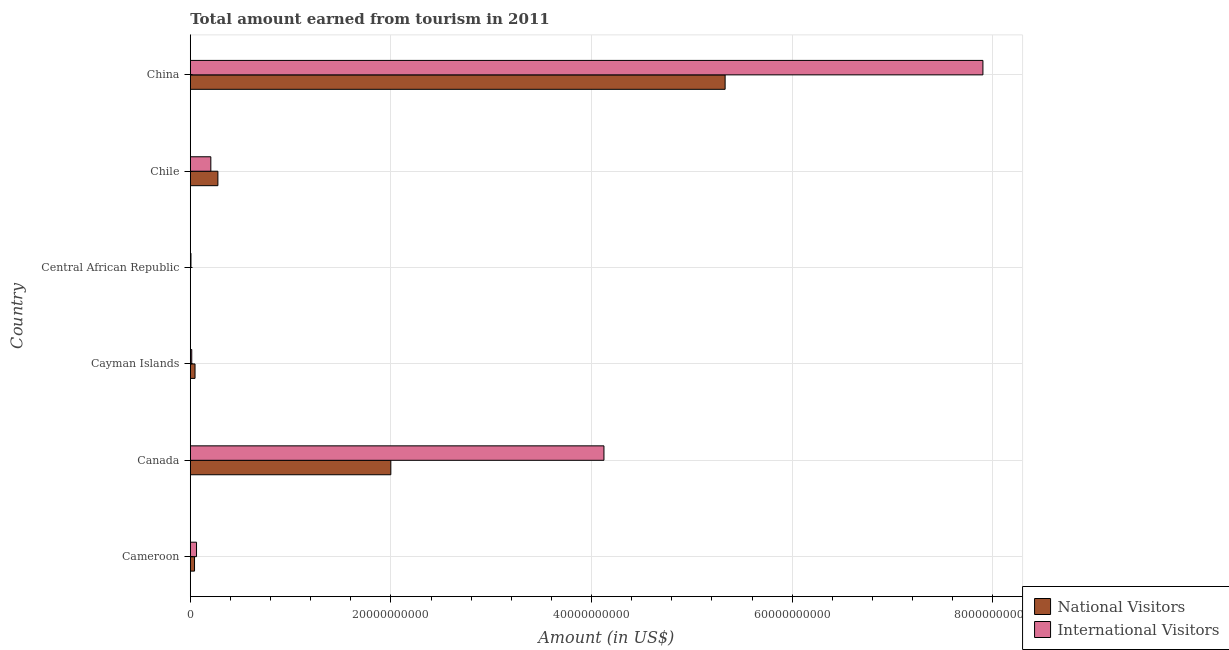How many groups of bars are there?
Offer a very short reply. 6. Are the number of bars on each tick of the Y-axis equal?
Ensure brevity in your answer.  Yes. How many bars are there on the 3rd tick from the top?
Provide a succinct answer. 2. How many bars are there on the 6th tick from the bottom?
Provide a succinct answer. 2. What is the label of the 6th group of bars from the top?
Your response must be concise. Cameroon. In how many cases, is the number of bars for a given country not equal to the number of legend labels?
Offer a very short reply. 0. What is the amount earned from national visitors in Cameroon?
Provide a short and direct response. 4.23e+08. Across all countries, what is the maximum amount earned from national visitors?
Make the answer very short. 5.33e+1. Across all countries, what is the minimum amount earned from international visitors?
Make the answer very short. 6.80e+07. In which country was the amount earned from national visitors minimum?
Give a very brief answer. Central African Republic. What is the total amount earned from international visitors in the graph?
Your answer should be very brief. 1.23e+11. What is the difference between the amount earned from national visitors in Cayman Islands and that in Central African Republic?
Provide a short and direct response. 4.57e+08. What is the difference between the amount earned from international visitors in Cayman Islands and the amount earned from national visitors in Chile?
Your response must be concise. -2.61e+09. What is the average amount earned from national visitors per country?
Your answer should be very brief. 1.28e+1. What is the difference between the amount earned from international visitors and amount earned from national visitors in Chile?
Keep it short and to the point. -7.04e+08. In how many countries, is the amount earned from international visitors greater than 36000000000 US$?
Provide a short and direct response. 2. What is the ratio of the amount earned from national visitors in Canada to that in Central African Republic?
Offer a very short reply. 1332.6. What is the difference between the highest and the second highest amount earned from international visitors?
Provide a succinct answer. 3.78e+1. What is the difference between the highest and the lowest amount earned from international visitors?
Your response must be concise. 7.89e+1. What does the 2nd bar from the top in Canada represents?
Give a very brief answer. National Visitors. What does the 2nd bar from the bottom in Chile represents?
Offer a very short reply. International Visitors. How many bars are there?
Your response must be concise. 12. How many countries are there in the graph?
Your answer should be compact. 6. What is the difference between two consecutive major ticks on the X-axis?
Your response must be concise. 2.00e+1. Are the values on the major ticks of X-axis written in scientific E-notation?
Offer a very short reply. No. Does the graph contain any zero values?
Your answer should be very brief. No. Where does the legend appear in the graph?
Give a very brief answer. Bottom right. How are the legend labels stacked?
Make the answer very short. Vertical. What is the title of the graph?
Provide a succinct answer. Total amount earned from tourism in 2011. What is the label or title of the X-axis?
Provide a short and direct response. Amount (in US$). What is the Amount (in US$) of National Visitors in Cameroon?
Ensure brevity in your answer.  4.23e+08. What is the Amount (in US$) of International Visitors in Cameroon?
Your response must be concise. 6.22e+08. What is the Amount (in US$) in National Visitors in Canada?
Your response must be concise. 2.00e+1. What is the Amount (in US$) in International Visitors in Canada?
Your response must be concise. 4.12e+1. What is the Amount (in US$) of National Visitors in Cayman Islands?
Offer a terse response. 4.72e+08. What is the Amount (in US$) in International Visitors in Cayman Islands?
Ensure brevity in your answer.  1.45e+08. What is the Amount (in US$) in National Visitors in Central African Republic?
Your response must be concise. 1.50e+07. What is the Amount (in US$) in International Visitors in Central African Republic?
Offer a very short reply. 6.80e+07. What is the Amount (in US$) of National Visitors in Chile?
Offer a terse response. 2.75e+09. What is the Amount (in US$) in International Visitors in Chile?
Your answer should be compact. 2.05e+09. What is the Amount (in US$) in National Visitors in China?
Make the answer very short. 5.33e+1. What is the Amount (in US$) in International Visitors in China?
Offer a terse response. 7.90e+1. Across all countries, what is the maximum Amount (in US$) in National Visitors?
Your answer should be very brief. 5.33e+1. Across all countries, what is the maximum Amount (in US$) in International Visitors?
Provide a succinct answer. 7.90e+1. Across all countries, what is the minimum Amount (in US$) of National Visitors?
Provide a succinct answer. 1.50e+07. Across all countries, what is the minimum Amount (in US$) in International Visitors?
Provide a short and direct response. 6.80e+07. What is the total Amount (in US$) of National Visitors in the graph?
Provide a short and direct response. 7.70e+1. What is the total Amount (in US$) of International Visitors in the graph?
Give a very brief answer. 1.23e+11. What is the difference between the Amount (in US$) of National Visitors in Cameroon and that in Canada?
Offer a very short reply. -1.96e+1. What is the difference between the Amount (in US$) in International Visitors in Cameroon and that in Canada?
Give a very brief answer. -4.06e+1. What is the difference between the Amount (in US$) in National Visitors in Cameroon and that in Cayman Islands?
Your response must be concise. -4.90e+07. What is the difference between the Amount (in US$) in International Visitors in Cameroon and that in Cayman Islands?
Ensure brevity in your answer.  4.77e+08. What is the difference between the Amount (in US$) of National Visitors in Cameroon and that in Central African Republic?
Provide a succinct answer. 4.08e+08. What is the difference between the Amount (in US$) in International Visitors in Cameroon and that in Central African Republic?
Your response must be concise. 5.54e+08. What is the difference between the Amount (in US$) in National Visitors in Cameroon and that in Chile?
Your response must be concise. -2.33e+09. What is the difference between the Amount (in US$) of International Visitors in Cameroon and that in Chile?
Offer a terse response. -1.42e+09. What is the difference between the Amount (in US$) in National Visitors in Cameroon and that in China?
Give a very brief answer. -5.29e+1. What is the difference between the Amount (in US$) of International Visitors in Cameroon and that in China?
Provide a succinct answer. -7.84e+1. What is the difference between the Amount (in US$) in National Visitors in Canada and that in Cayman Islands?
Your answer should be compact. 1.95e+1. What is the difference between the Amount (in US$) of International Visitors in Canada and that in Cayman Islands?
Keep it short and to the point. 4.11e+1. What is the difference between the Amount (in US$) in National Visitors in Canada and that in Central African Republic?
Your response must be concise. 2.00e+1. What is the difference between the Amount (in US$) in International Visitors in Canada and that in Central African Republic?
Provide a succinct answer. 4.12e+1. What is the difference between the Amount (in US$) in National Visitors in Canada and that in Chile?
Offer a very short reply. 1.72e+1. What is the difference between the Amount (in US$) in International Visitors in Canada and that in Chile?
Offer a very short reply. 3.92e+1. What is the difference between the Amount (in US$) of National Visitors in Canada and that in China?
Offer a terse response. -3.33e+1. What is the difference between the Amount (in US$) of International Visitors in Canada and that in China?
Provide a succinct answer. -3.78e+1. What is the difference between the Amount (in US$) in National Visitors in Cayman Islands and that in Central African Republic?
Offer a very short reply. 4.57e+08. What is the difference between the Amount (in US$) of International Visitors in Cayman Islands and that in Central African Republic?
Provide a short and direct response. 7.70e+07. What is the difference between the Amount (in US$) of National Visitors in Cayman Islands and that in Chile?
Keep it short and to the point. -2.28e+09. What is the difference between the Amount (in US$) in International Visitors in Cayman Islands and that in Chile?
Your answer should be compact. -1.90e+09. What is the difference between the Amount (in US$) in National Visitors in Cayman Islands and that in China?
Make the answer very short. -5.28e+1. What is the difference between the Amount (in US$) in International Visitors in Cayman Islands and that in China?
Give a very brief answer. -7.89e+1. What is the difference between the Amount (in US$) in National Visitors in Central African Republic and that in Chile?
Give a very brief answer. -2.74e+09. What is the difference between the Amount (in US$) of International Visitors in Central African Republic and that in Chile?
Give a very brief answer. -1.98e+09. What is the difference between the Amount (in US$) of National Visitors in Central African Republic and that in China?
Provide a succinct answer. -5.33e+1. What is the difference between the Amount (in US$) in International Visitors in Central African Republic and that in China?
Offer a very short reply. -7.89e+1. What is the difference between the Amount (in US$) of National Visitors in Chile and that in China?
Your answer should be very brief. -5.06e+1. What is the difference between the Amount (in US$) of International Visitors in Chile and that in China?
Provide a short and direct response. -7.70e+1. What is the difference between the Amount (in US$) in National Visitors in Cameroon and the Amount (in US$) in International Visitors in Canada?
Your response must be concise. -4.08e+1. What is the difference between the Amount (in US$) of National Visitors in Cameroon and the Amount (in US$) of International Visitors in Cayman Islands?
Your answer should be compact. 2.78e+08. What is the difference between the Amount (in US$) in National Visitors in Cameroon and the Amount (in US$) in International Visitors in Central African Republic?
Your answer should be compact. 3.55e+08. What is the difference between the Amount (in US$) of National Visitors in Cameroon and the Amount (in US$) of International Visitors in Chile?
Provide a short and direct response. -1.62e+09. What is the difference between the Amount (in US$) in National Visitors in Cameroon and the Amount (in US$) in International Visitors in China?
Keep it short and to the point. -7.86e+1. What is the difference between the Amount (in US$) in National Visitors in Canada and the Amount (in US$) in International Visitors in Cayman Islands?
Offer a terse response. 1.98e+1. What is the difference between the Amount (in US$) in National Visitors in Canada and the Amount (in US$) in International Visitors in Central African Republic?
Give a very brief answer. 1.99e+1. What is the difference between the Amount (in US$) of National Visitors in Canada and the Amount (in US$) of International Visitors in Chile?
Your answer should be very brief. 1.79e+1. What is the difference between the Amount (in US$) of National Visitors in Canada and the Amount (in US$) of International Visitors in China?
Keep it short and to the point. -5.90e+1. What is the difference between the Amount (in US$) in National Visitors in Cayman Islands and the Amount (in US$) in International Visitors in Central African Republic?
Your answer should be compact. 4.04e+08. What is the difference between the Amount (in US$) in National Visitors in Cayman Islands and the Amount (in US$) in International Visitors in Chile?
Provide a succinct answer. -1.58e+09. What is the difference between the Amount (in US$) of National Visitors in Cayman Islands and the Amount (in US$) of International Visitors in China?
Your answer should be compact. -7.85e+1. What is the difference between the Amount (in US$) in National Visitors in Central African Republic and the Amount (in US$) in International Visitors in Chile?
Your answer should be compact. -2.03e+09. What is the difference between the Amount (in US$) in National Visitors in Central African Republic and the Amount (in US$) in International Visitors in China?
Provide a succinct answer. -7.90e+1. What is the difference between the Amount (in US$) in National Visitors in Chile and the Amount (in US$) in International Visitors in China?
Give a very brief answer. -7.63e+1. What is the average Amount (in US$) of National Visitors per country?
Provide a succinct answer. 1.28e+1. What is the average Amount (in US$) of International Visitors per country?
Keep it short and to the point. 2.05e+1. What is the difference between the Amount (in US$) in National Visitors and Amount (in US$) in International Visitors in Cameroon?
Your answer should be compact. -1.99e+08. What is the difference between the Amount (in US$) in National Visitors and Amount (in US$) in International Visitors in Canada?
Your answer should be very brief. -2.12e+1. What is the difference between the Amount (in US$) in National Visitors and Amount (in US$) in International Visitors in Cayman Islands?
Offer a terse response. 3.27e+08. What is the difference between the Amount (in US$) in National Visitors and Amount (in US$) in International Visitors in Central African Republic?
Your response must be concise. -5.30e+07. What is the difference between the Amount (in US$) of National Visitors and Amount (in US$) of International Visitors in Chile?
Your answer should be compact. 7.04e+08. What is the difference between the Amount (in US$) of National Visitors and Amount (in US$) of International Visitors in China?
Your answer should be very brief. -2.57e+1. What is the ratio of the Amount (in US$) of National Visitors in Cameroon to that in Canada?
Make the answer very short. 0.02. What is the ratio of the Amount (in US$) in International Visitors in Cameroon to that in Canada?
Keep it short and to the point. 0.02. What is the ratio of the Amount (in US$) of National Visitors in Cameroon to that in Cayman Islands?
Make the answer very short. 0.9. What is the ratio of the Amount (in US$) of International Visitors in Cameroon to that in Cayman Islands?
Ensure brevity in your answer.  4.29. What is the ratio of the Amount (in US$) of National Visitors in Cameroon to that in Central African Republic?
Offer a terse response. 28.2. What is the ratio of the Amount (in US$) in International Visitors in Cameroon to that in Central African Republic?
Offer a very short reply. 9.15. What is the ratio of the Amount (in US$) of National Visitors in Cameroon to that in Chile?
Your answer should be compact. 0.15. What is the ratio of the Amount (in US$) in International Visitors in Cameroon to that in Chile?
Offer a terse response. 0.3. What is the ratio of the Amount (in US$) of National Visitors in Cameroon to that in China?
Your answer should be compact. 0.01. What is the ratio of the Amount (in US$) in International Visitors in Cameroon to that in China?
Ensure brevity in your answer.  0.01. What is the ratio of the Amount (in US$) in National Visitors in Canada to that in Cayman Islands?
Ensure brevity in your answer.  42.35. What is the ratio of the Amount (in US$) in International Visitors in Canada to that in Cayman Islands?
Offer a terse response. 284.37. What is the ratio of the Amount (in US$) in National Visitors in Canada to that in Central African Republic?
Offer a terse response. 1332.6. What is the ratio of the Amount (in US$) in International Visitors in Canada to that in Central African Republic?
Your response must be concise. 606.38. What is the ratio of the Amount (in US$) in National Visitors in Canada to that in Chile?
Give a very brief answer. 7.27. What is the ratio of the Amount (in US$) in International Visitors in Canada to that in Chile?
Your answer should be compact. 20.14. What is the ratio of the Amount (in US$) in National Visitors in Canada to that in China?
Your response must be concise. 0.37. What is the ratio of the Amount (in US$) of International Visitors in Canada to that in China?
Give a very brief answer. 0.52. What is the ratio of the Amount (in US$) of National Visitors in Cayman Islands to that in Central African Republic?
Provide a short and direct response. 31.47. What is the ratio of the Amount (in US$) of International Visitors in Cayman Islands to that in Central African Republic?
Your response must be concise. 2.13. What is the ratio of the Amount (in US$) in National Visitors in Cayman Islands to that in Chile?
Keep it short and to the point. 0.17. What is the ratio of the Amount (in US$) in International Visitors in Cayman Islands to that in Chile?
Offer a terse response. 0.07. What is the ratio of the Amount (in US$) in National Visitors in Cayman Islands to that in China?
Provide a succinct answer. 0.01. What is the ratio of the Amount (in US$) in International Visitors in Cayman Islands to that in China?
Your answer should be very brief. 0. What is the ratio of the Amount (in US$) in National Visitors in Central African Republic to that in Chile?
Provide a short and direct response. 0.01. What is the ratio of the Amount (in US$) of International Visitors in Central African Republic to that in Chile?
Your answer should be very brief. 0.03. What is the ratio of the Amount (in US$) in National Visitors in Central African Republic to that in China?
Your answer should be very brief. 0. What is the ratio of the Amount (in US$) of International Visitors in Central African Republic to that in China?
Provide a succinct answer. 0. What is the ratio of the Amount (in US$) of National Visitors in Chile to that in China?
Provide a short and direct response. 0.05. What is the ratio of the Amount (in US$) in International Visitors in Chile to that in China?
Offer a terse response. 0.03. What is the difference between the highest and the second highest Amount (in US$) of National Visitors?
Offer a very short reply. 3.33e+1. What is the difference between the highest and the second highest Amount (in US$) in International Visitors?
Your response must be concise. 3.78e+1. What is the difference between the highest and the lowest Amount (in US$) in National Visitors?
Offer a terse response. 5.33e+1. What is the difference between the highest and the lowest Amount (in US$) of International Visitors?
Offer a very short reply. 7.89e+1. 